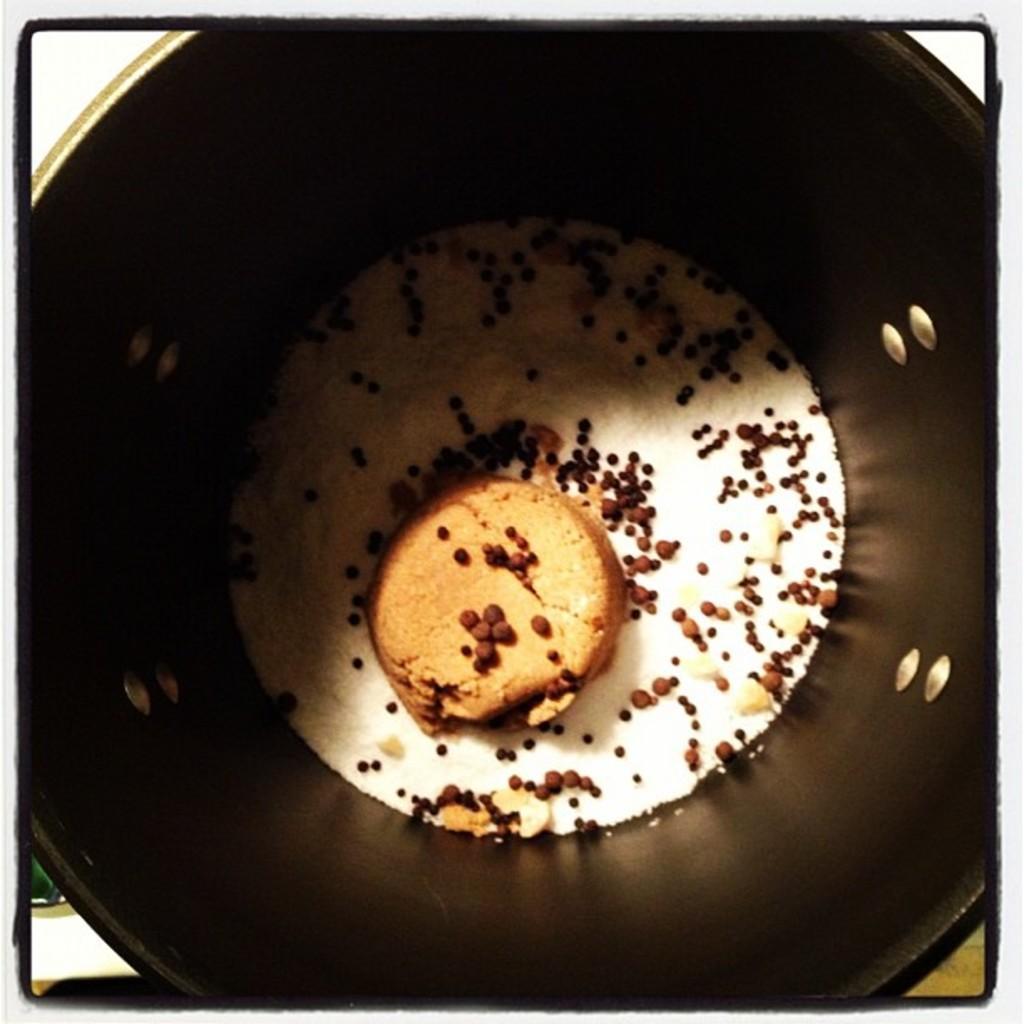Can you describe this image briefly? There is a biscuit and other ingredients in a bucket. The background is white in color. 